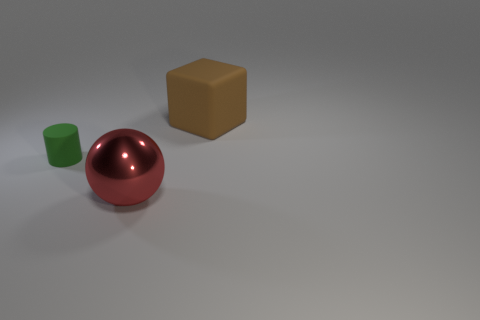Add 1 big brown cylinders. How many objects exist? 4 Subtract all cylinders. How many objects are left? 2 Add 2 big cyan rubber spheres. How many big cyan rubber spheres exist? 2 Subtract 1 red balls. How many objects are left? 2 Subtract all red matte cubes. Subtract all large red shiny spheres. How many objects are left? 2 Add 2 large brown blocks. How many large brown blocks are left? 3 